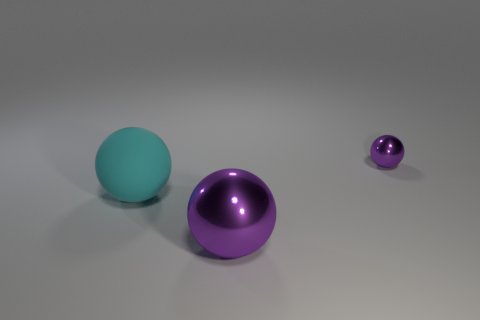Is the small purple sphere made of the same material as the cyan sphere?
Ensure brevity in your answer.  No. Are there any other things that have the same material as the tiny purple sphere?
Offer a very short reply. Yes. Is the number of purple shiny spheres that are on the left side of the small object greater than the number of shiny objects?
Make the answer very short. No. Does the big shiny thing have the same color as the rubber ball?
Offer a very short reply. No. What number of green shiny objects are the same shape as the large purple object?
Keep it short and to the point. 0. What is the size of the other purple sphere that is the same material as the big purple ball?
Your answer should be very brief. Small. What is the color of the sphere that is to the right of the large matte ball and behind the big purple thing?
Your answer should be very brief. Purple. What number of purple shiny spheres are the same size as the cyan thing?
Your response must be concise. 1. The other object that is the same color as the tiny object is what size?
Provide a short and direct response. Large. What is the size of the object that is left of the small purple sphere and behind the big purple metallic sphere?
Offer a terse response. Large. 